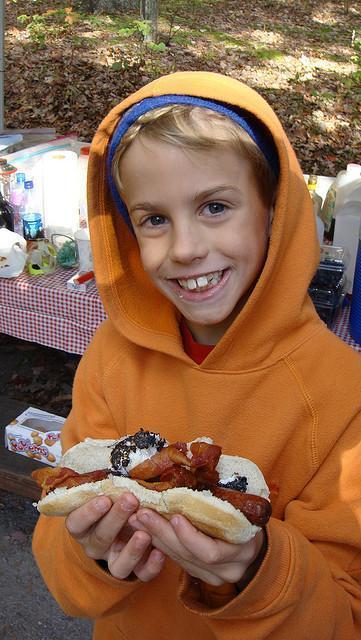How many signs are hanging above the toilet that are not written in english?
Give a very brief answer. 0. 